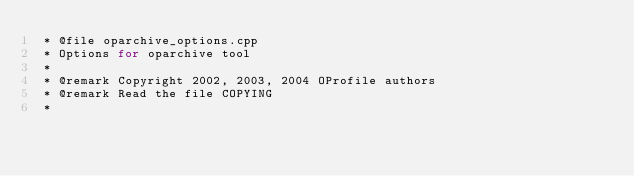<code> <loc_0><loc_0><loc_500><loc_500><_C++_> * @file oparchive_options.cpp
 * Options for oparchive tool
 *
 * @remark Copyright 2002, 2003, 2004 OProfile authors
 * @remark Read the file COPYING
 *</code> 